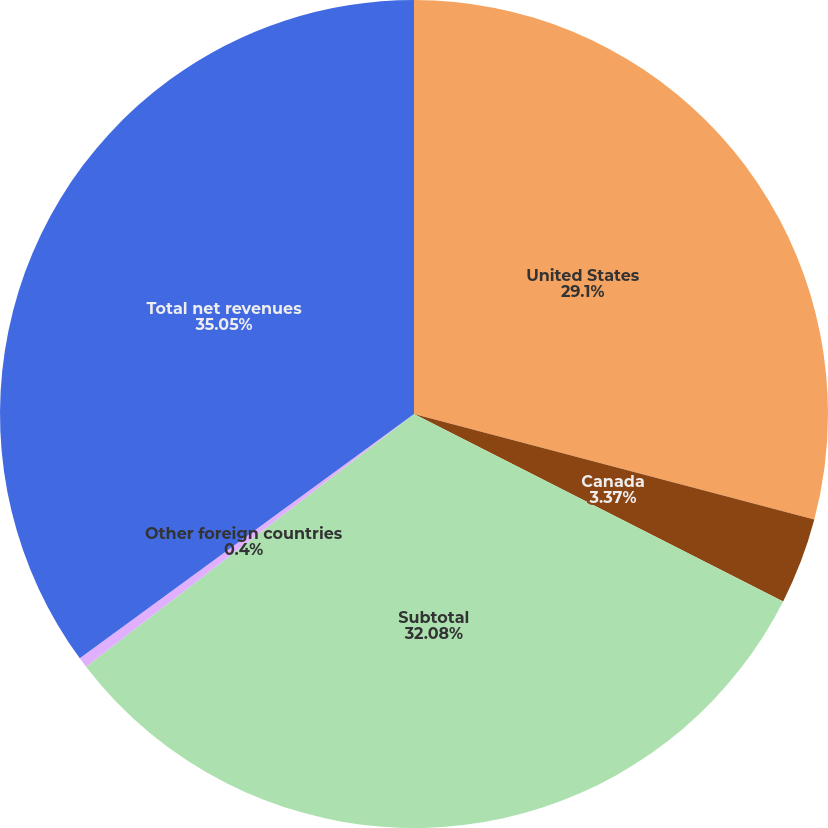<chart> <loc_0><loc_0><loc_500><loc_500><pie_chart><fcel>United States<fcel>Canada<fcel>Subtotal<fcel>Other foreign countries<fcel>Total net revenues<nl><fcel>29.1%<fcel>3.37%<fcel>32.07%<fcel>0.4%<fcel>35.04%<nl></chart> 